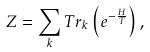<formula> <loc_0><loc_0><loc_500><loc_500>Z = \sum _ { k } T r _ { k } \left ( e ^ { - \frac { H } { T } } \right ) ,</formula> 